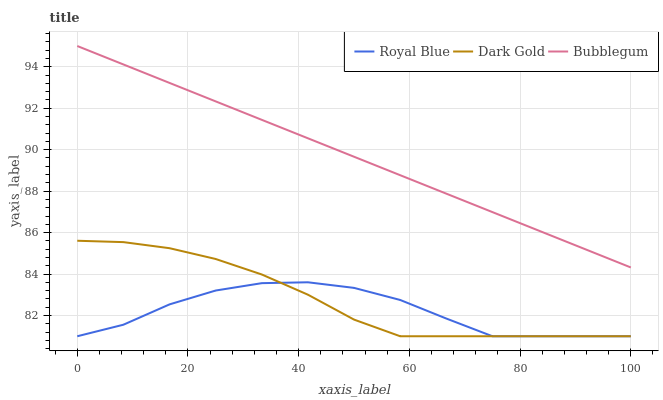Does Dark Gold have the minimum area under the curve?
Answer yes or no. No. Does Dark Gold have the maximum area under the curve?
Answer yes or no. No. Is Dark Gold the smoothest?
Answer yes or no. No. Is Dark Gold the roughest?
Answer yes or no. No. Does Bubblegum have the lowest value?
Answer yes or no. No. Does Dark Gold have the highest value?
Answer yes or no. No. Is Dark Gold less than Bubblegum?
Answer yes or no. Yes. Is Bubblegum greater than Dark Gold?
Answer yes or no. Yes. Does Dark Gold intersect Bubblegum?
Answer yes or no. No. 